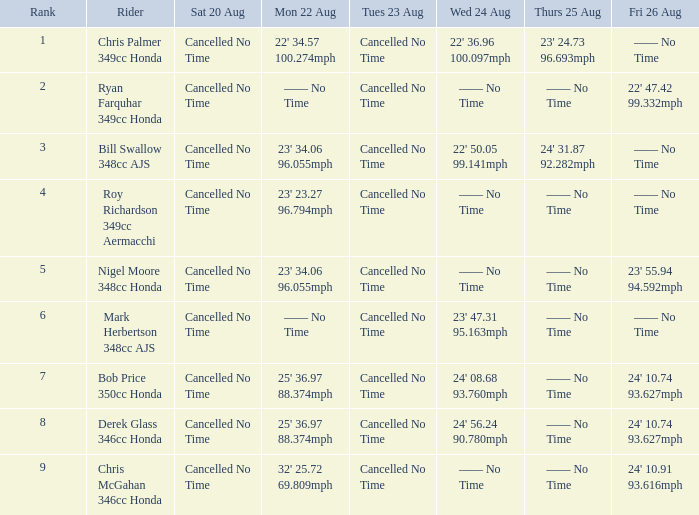809mph? 24' 10.91 93.616mph. 